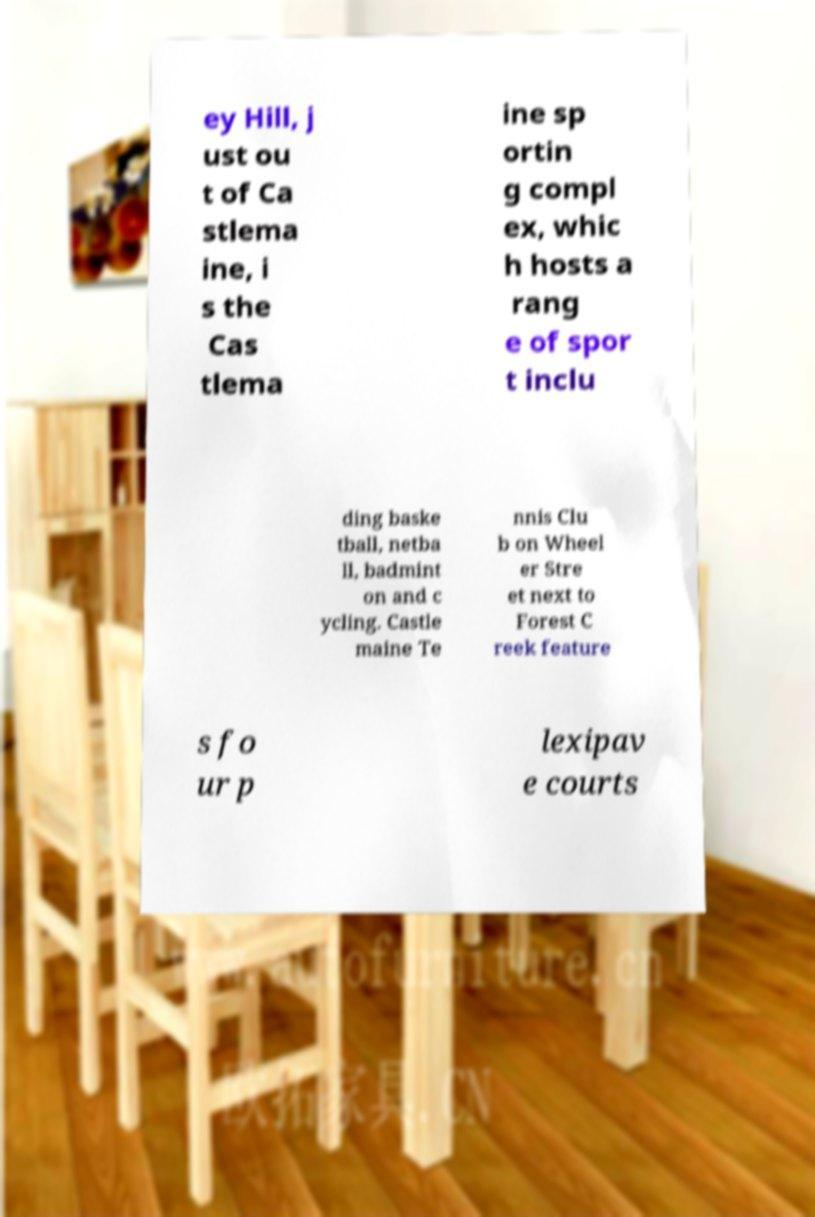Please identify and transcribe the text found in this image. ey Hill, j ust ou t of Ca stlema ine, i s the Cas tlema ine sp ortin g compl ex, whic h hosts a rang e of spor t inclu ding baske tball, netba ll, badmint on and c ycling. Castle maine Te nnis Clu b on Wheel er Stre et next to Forest C reek feature s fo ur p lexipav e courts 